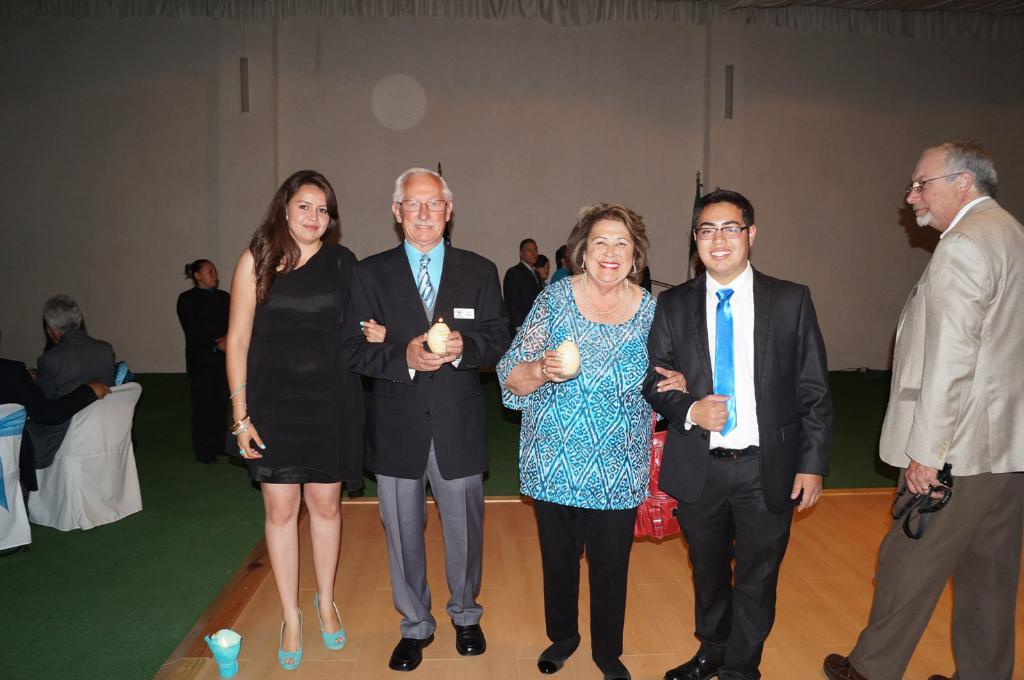What are the people in the image doing? The people in the image are standing in the center and sitting on chairs at the left side. Can you describe the background of the image? There is a wall in the background of the image. What type of skirt can be seen hanging on the wall in the image? There is no skirt present in the image; the wall is the only feature mentioned in the background. 